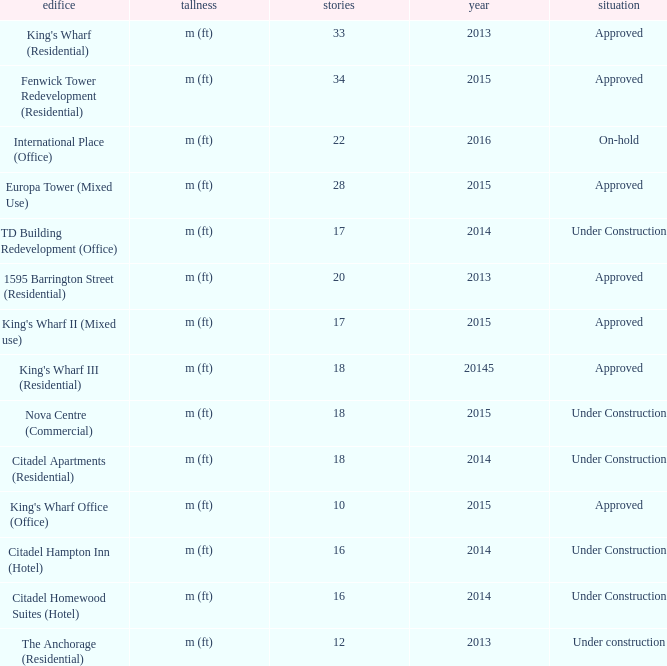What building shows 2013 and has more than 20 floors? King's Wharf (Residential). 